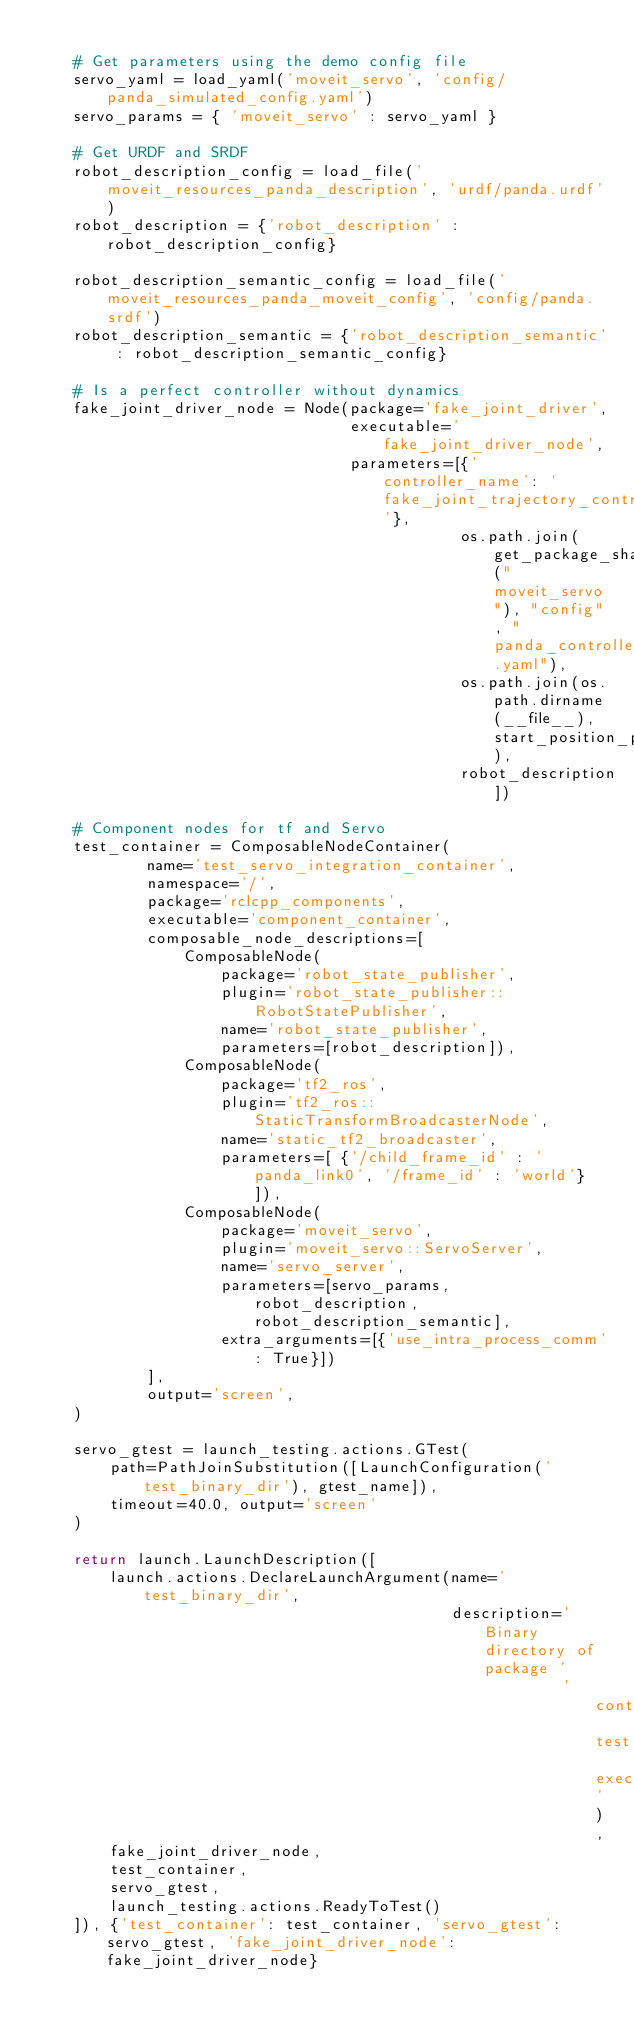Convert code to text. <code><loc_0><loc_0><loc_500><loc_500><_Python_>    
    # Get parameters using the demo config file
    servo_yaml = load_yaml('moveit_servo', 'config/panda_simulated_config.yaml')
    servo_params = { 'moveit_servo' : servo_yaml }

    # Get URDF and SRDF
    robot_description_config = load_file('moveit_resources_panda_description', 'urdf/panda.urdf')
    robot_description = {'robot_description' : robot_description_config}

    robot_description_semantic_config = load_file('moveit_resources_panda_moveit_config', 'config/panda.srdf')
    robot_description_semantic = {'robot_description_semantic' : robot_description_semantic_config}

    # Is a perfect controller without dynamics
    fake_joint_driver_node = Node(package='fake_joint_driver',
                                  executable='fake_joint_driver_node',
                                  parameters=[{'controller_name': 'fake_joint_trajectory_controller'},
                                              os.path.join(get_package_share_directory("moveit_servo"), "config", "panda_controllers.yaml"),
                                              os.path.join(os.path.dirname(__file__), start_position_path),
                                              robot_description])

    # Component nodes for tf and Servo
    test_container = ComposableNodeContainer(
            name='test_servo_integration_container',
            namespace='/',
            package='rclcpp_components',
            executable='component_container',
            composable_node_descriptions=[
                ComposableNode(
                    package='robot_state_publisher',
                    plugin='robot_state_publisher::RobotStatePublisher',
                    name='robot_state_publisher',
                    parameters=[robot_description]),
                ComposableNode(
                    package='tf2_ros',
                    plugin='tf2_ros::StaticTransformBroadcasterNode',
                    name='static_tf2_broadcaster',
                    parameters=[ {'/child_frame_id' : 'panda_link0', '/frame_id' : 'world'} ]),
                ComposableNode(
                    package='moveit_servo',
                    plugin='moveit_servo::ServoServer',
                    name='servo_server',
                    parameters=[servo_params, robot_description, robot_description_semantic],
                    extra_arguments=[{'use_intra_process_comm': True}])
            ],
            output='screen',
    )

    servo_gtest = launch_testing.actions.GTest(
        path=PathJoinSubstitution([LaunchConfiguration('test_binary_dir'), gtest_name]),
        timeout=40.0, output='screen'
    )

    return launch.LaunchDescription([
        launch.actions.DeclareLaunchArgument(name='test_binary_dir',
                                             description='Binary directory of package '
                                                         'containing test executables'),
        fake_joint_driver_node,
        test_container,
        servo_gtest,
        launch_testing.actions.ReadyToTest()
    ]), {'test_container': test_container, 'servo_gtest': servo_gtest, 'fake_joint_driver_node': fake_joint_driver_node}
</code> 